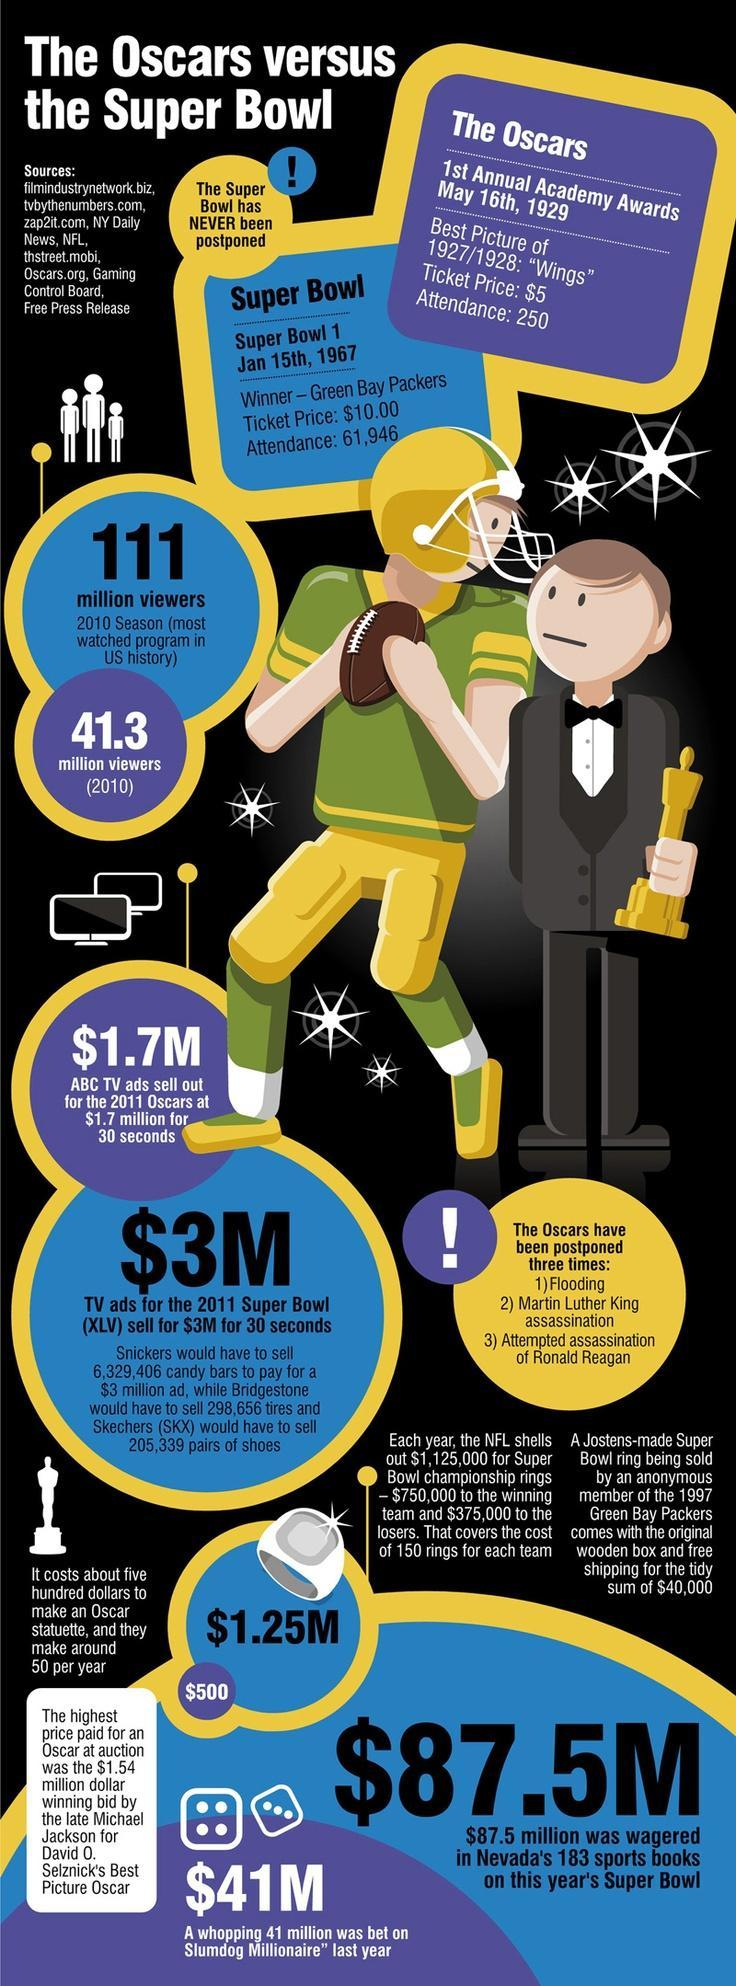Who won the first Super Bowl Championship title?
Answer the question with a short phrase. Green Bay Packers Which movie has won an Oscar for the best picture in 1927/1928? Wings How many people attended the first annual academy awards? 250 How many people watched the 2010 Super Bowl season in the US? 111 million viewers 